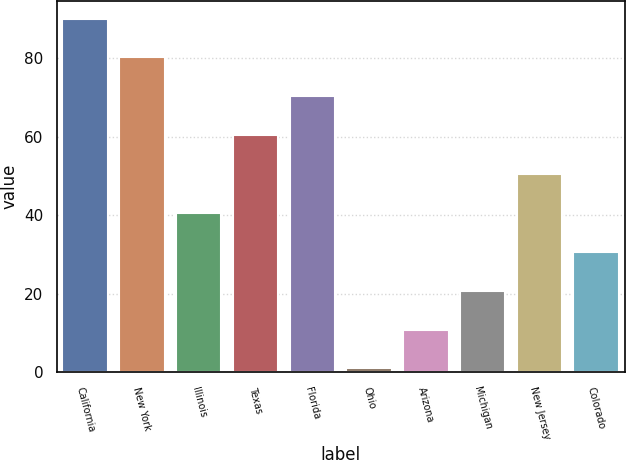Convert chart to OTSL. <chart><loc_0><loc_0><loc_500><loc_500><bar_chart><fcel>California<fcel>New York<fcel>Illinois<fcel>Texas<fcel>Florida<fcel>Ohio<fcel>Arizona<fcel>Michigan<fcel>New Jersey<fcel>Colorado<nl><fcel>90.1<fcel>80.2<fcel>40.6<fcel>60.4<fcel>70.3<fcel>1<fcel>10.9<fcel>20.8<fcel>50.5<fcel>30.7<nl></chart> 